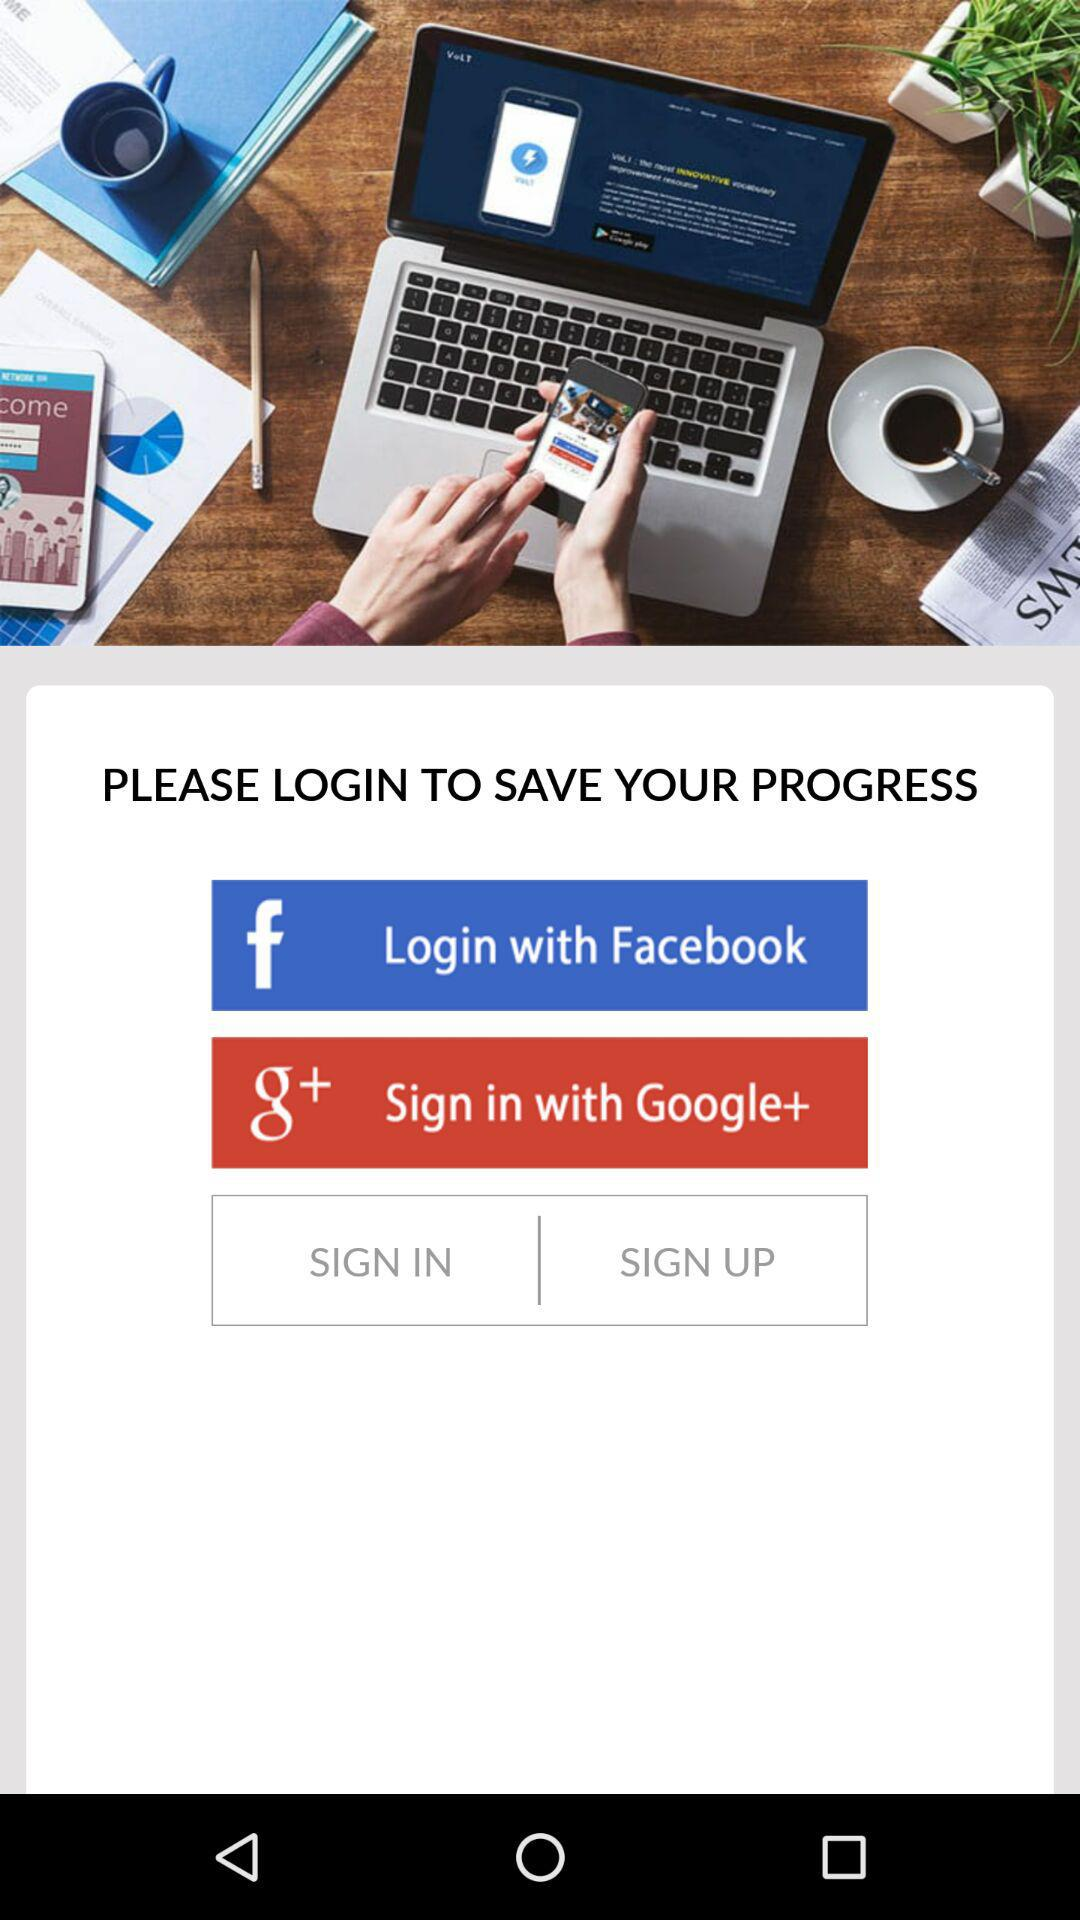What do we need to do to save our progress? You need to log in to save your progress. 